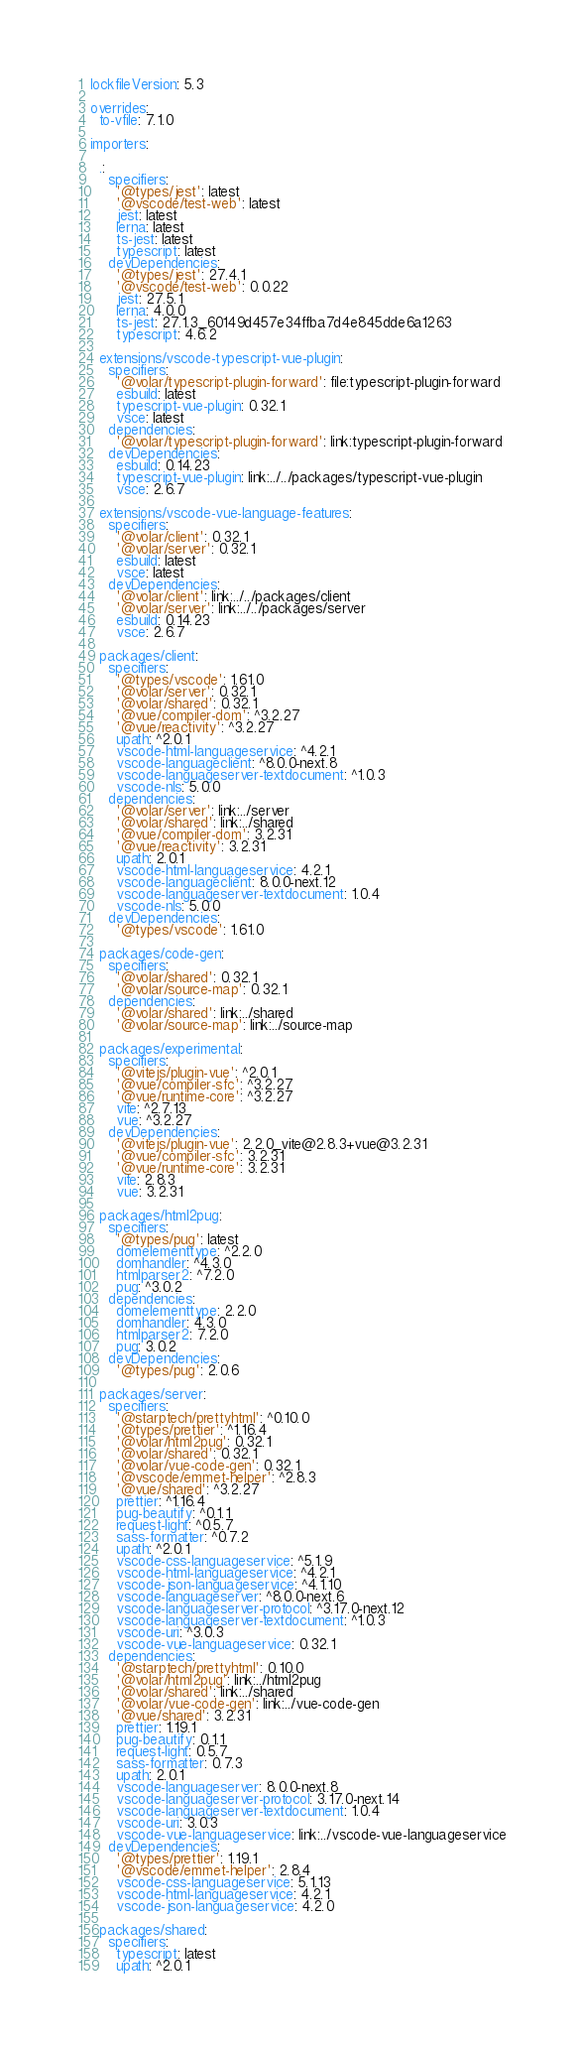<code> <loc_0><loc_0><loc_500><loc_500><_YAML_>lockfileVersion: 5.3

overrides:
  to-vfile: 7.1.0

importers:

  .:
    specifiers:
      '@types/jest': latest
      '@vscode/test-web': latest
      jest: latest
      lerna: latest
      ts-jest: latest
      typescript: latest
    devDependencies:
      '@types/jest': 27.4.1
      '@vscode/test-web': 0.0.22
      jest: 27.5.1
      lerna: 4.0.0
      ts-jest: 27.1.3_60149d457e34ffba7d4e845dde6a1263
      typescript: 4.6.2

  extensions/vscode-typescript-vue-plugin:
    specifiers:
      '@volar/typescript-plugin-forward': file:typescript-plugin-forward
      esbuild: latest
      typescript-vue-plugin: 0.32.1
      vsce: latest
    dependencies:
      '@volar/typescript-plugin-forward': link:typescript-plugin-forward
    devDependencies:
      esbuild: 0.14.23
      typescript-vue-plugin: link:../../packages/typescript-vue-plugin
      vsce: 2.6.7

  extensions/vscode-vue-language-features:
    specifiers:
      '@volar/client': 0.32.1
      '@volar/server': 0.32.1
      esbuild: latest
      vsce: latest
    devDependencies:
      '@volar/client': link:../../packages/client
      '@volar/server': link:../../packages/server
      esbuild: 0.14.23
      vsce: 2.6.7

  packages/client:
    specifiers:
      '@types/vscode': 1.61.0
      '@volar/server': 0.32.1
      '@volar/shared': 0.32.1
      '@vue/compiler-dom': ^3.2.27
      '@vue/reactivity': ^3.2.27
      upath: ^2.0.1
      vscode-html-languageservice: ^4.2.1
      vscode-languageclient: ^8.0.0-next.8
      vscode-languageserver-textdocument: ^1.0.3
      vscode-nls: 5.0.0
    dependencies:
      '@volar/server': link:../server
      '@volar/shared': link:../shared
      '@vue/compiler-dom': 3.2.31
      '@vue/reactivity': 3.2.31
      upath: 2.0.1
      vscode-html-languageservice: 4.2.1
      vscode-languageclient: 8.0.0-next.12
      vscode-languageserver-textdocument: 1.0.4
      vscode-nls: 5.0.0
    devDependencies:
      '@types/vscode': 1.61.0

  packages/code-gen:
    specifiers:
      '@volar/shared': 0.32.1
      '@volar/source-map': 0.32.1
    dependencies:
      '@volar/shared': link:../shared
      '@volar/source-map': link:../source-map

  packages/experimental:
    specifiers:
      '@vitejs/plugin-vue': ^2.0.1
      '@vue/compiler-sfc': ^3.2.27
      '@vue/runtime-core': ^3.2.27
      vite: ^2.7.13
      vue: ^3.2.27
    devDependencies:
      '@vitejs/plugin-vue': 2.2.0_vite@2.8.3+vue@3.2.31
      '@vue/compiler-sfc': 3.2.31
      '@vue/runtime-core': 3.2.31
      vite: 2.8.3
      vue: 3.2.31

  packages/html2pug:
    specifiers:
      '@types/pug': latest
      domelementtype: ^2.2.0
      domhandler: ^4.3.0
      htmlparser2: ^7.2.0
      pug: ^3.0.2
    dependencies:
      domelementtype: 2.2.0
      domhandler: 4.3.0
      htmlparser2: 7.2.0
      pug: 3.0.2
    devDependencies:
      '@types/pug': 2.0.6

  packages/server:
    specifiers:
      '@starptech/prettyhtml': ^0.10.0
      '@types/prettier': ^1.16.4
      '@volar/html2pug': 0.32.1
      '@volar/shared': 0.32.1
      '@volar/vue-code-gen': 0.32.1
      '@vscode/emmet-helper': ^2.8.3
      '@vue/shared': ^3.2.27
      prettier: ^1.16.4
      pug-beautify: ^0.1.1
      request-light: ^0.5.7
      sass-formatter: ^0.7.2
      upath: ^2.0.1
      vscode-css-languageservice: ^5.1.9
      vscode-html-languageservice: ^4.2.1
      vscode-json-languageservice: ^4.1.10
      vscode-languageserver: ^8.0.0-next.6
      vscode-languageserver-protocol: ^3.17.0-next.12
      vscode-languageserver-textdocument: ^1.0.3
      vscode-uri: ^3.0.3
      vscode-vue-languageservice: 0.32.1
    dependencies:
      '@starptech/prettyhtml': 0.10.0
      '@volar/html2pug': link:../html2pug
      '@volar/shared': link:../shared
      '@volar/vue-code-gen': link:../vue-code-gen
      '@vue/shared': 3.2.31
      prettier: 1.19.1
      pug-beautify: 0.1.1
      request-light: 0.5.7
      sass-formatter: 0.7.3
      upath: 2.0.1
      vscode-languageserver: 8.0.0-next.8
      vscode-languageserver-protocol: 3.17.0-next.14
      vscode-languageserver-textdocument: 1.0.4
      vscode-uri: 3.0.3
      vscode-vue-languageservice: link:../vscode-vue-languageservice
    devDependencies:
      '@types/prettier': 1.19.1
      '@vscode/emmet-helper': 2.8.4
      vscode-css-languageservice: 5.1.13
      vscode-html-languageservice: 4.2.1
      vscode-json-languageservice: 4.2.0

  packages/shared:
    specifiers:
      typescript: latest
      upath: ^2.0.1</code> 